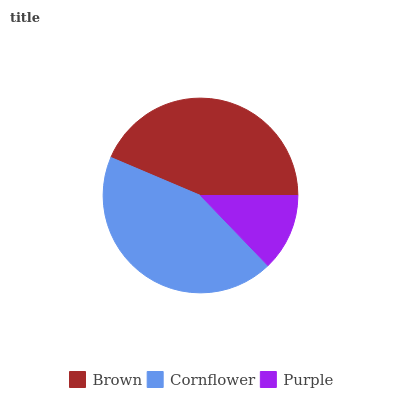Is Purple the minimum?
Answer yes or no. Yes. Is Brown the maximum?
Answer yes or no. Yes. Is Cornflower the minimum?
Answer yes or no. No. Is Cornflower the maximum?
Answer yes or no. No. Is Brown greater than Cornflower?
Answer yes or no. Yes. Is Cornflower less than Brown?
Answer yes or no. Yes. Is Cornflower greater than Brown?
Answer yes or no. No. Is Brown less than Cornflower?
Answer yes or no. No. Is Cornflower the high median?
Answer yes or no. Yes. Is Cornflower the low median?
Answer yes or no. Yes. Is Purple the high median?
Answer yes or no. No. Is Brown the low median?
Answer yes or no. No. 